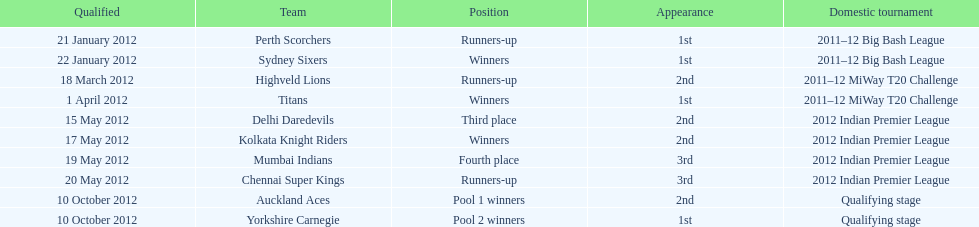What is the total number of teams? 10. 